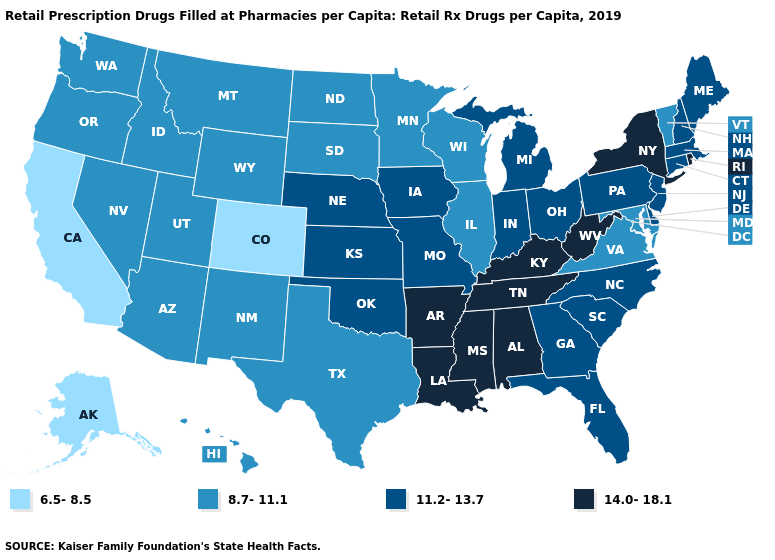Among the states that border Maryland , which have the lowest value?
Short answer required. Virginia. How many symbols are there in the legend?
Answer briefly. 4. Does Iowa have the lowest value in the MidWest?
Keep it brief. No. What is the value of New Mexico?
Answer briefly. 8.7-11.1. How many symbols are there in the legend?
Answer briefly. 4. Among the states that border Massachusetts , does New Hampshire have the lowest value?
Quick response, please. No. What is the value of Pennsylvania?
Be succinct. 11.2-13.7. Name the states that have a value in the range 6.5-8.5?
Give a very brief answer. Alaska, California, Colorado. Name the states that have a value in the range 6.5-8.5?
Write a very short answer. Alaska, California, Colorado. Does New Jersey have the highest value in the Northeast?
Write a very short answer. No. Among the states that border Virginia , which have the lowest value?
Concise answer only. Maryland. Name the states that have a value in the range 6.5-8.5?
Concise answer only. Alaska, California, Colorado. What is the lowest value in the West?
Give a very brief answer. 6.5-8.5. Does Minnesota have the highest value in the USA?
Keep it brief. No. Name the states that have a value in the range 6.5-8.5?
Write a very short answer. Alaska, California, Colorado. 